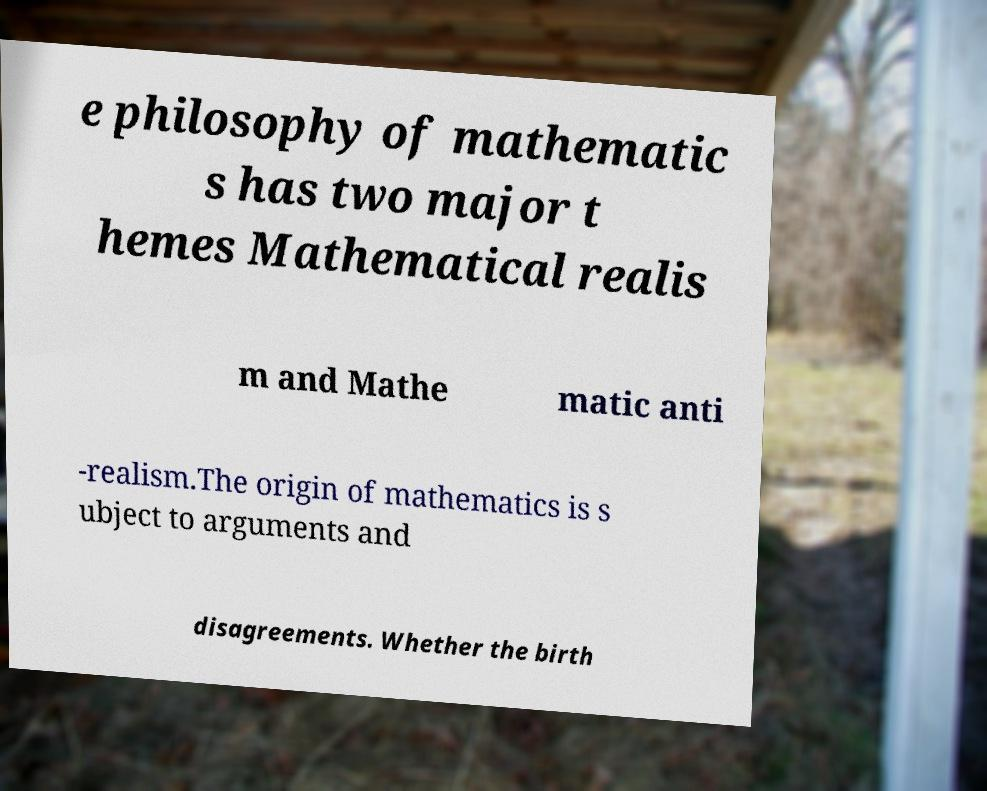There's text embedded in this image that I need extracted. Can you transcribe it verbatim? e philosophy of mathematic s has two major t hemes Mathematical realis m and Mathe matic anti -realism.The origin of mathematics is s ubject to arguments and disagreements. Whether the birth 